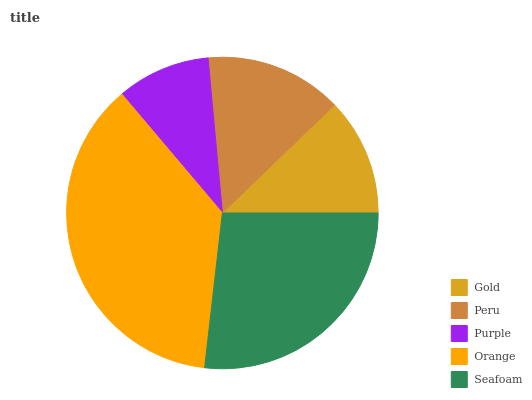Is Purple the minimum?
Answer yes or no. Yes. Is Orange the maximum?
Answer yes or no. Yes. Is Peru the minimum?
Answer yes or no. No. Is Peru the maximum?
Answer yes or no. No. Is Peru greater than Gold?
Answer yes or no. Yes. Is Gold less than Peru?
Answer yes or no. Yes. Is Gold greater than Peru?
Answer yes or no. No. Is Peru less than Gold?
Answer yes or no. No. Is Peru the high median?
Answer yes or no. Yes. Is Peru the low median?
Answer yes or no. Yes. Is Gold the high median?
Answer yes or no. No. Is Purple the low median?
Answer yes or no. No. 